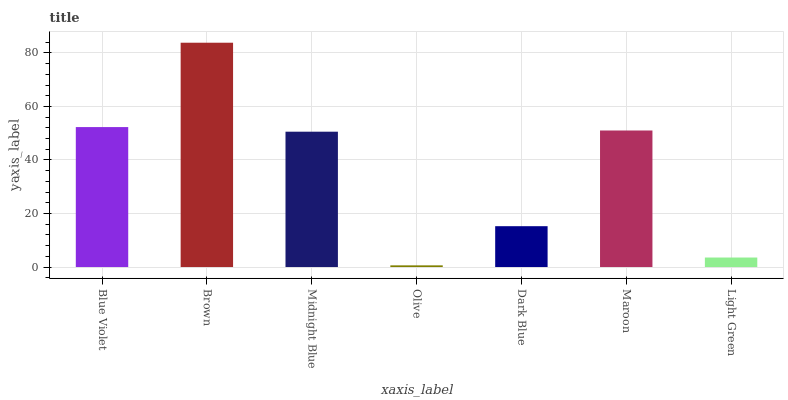Is Midnight Blue the minimum?
Answer yes or no. No. Is Midnight Blue the maximum?
Answer yes or no. No. Is Brown greater than Midnight Blue?
Answer yes or no. Yes. Is Midnight Blue less than Brown?
Answer yes or no. Yes. Is Midnight Blue greater than Brown?
Answer yes or no. No. Is Brown less than Midnight Blue?
Answer yes or no. No. Is Midnight Blue the high median?
Answer yes or no. Yes. Is Midnight Blue the low median?
Answer yes or no. Yes. Is Olive the high median?
Answer yes or no. No. Is Dark Blue the low median?
Answer yes or no. No. 